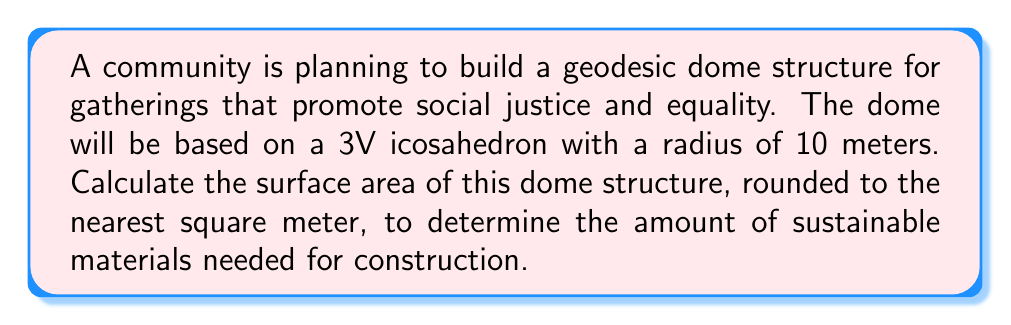Solve this math problem. To calculate the surface area of a geodesic dome based on a 3V icosahedron, we'll follow these steps:

1. Calculate the number of triangles:
   A 3V icosahedron has $10T + 20T = 30T$ triangles, where $T = 3^2 = 9$.
   Total triangles = $30 \times 9 = 270$

2. Calculate the surface area of one spherical triangle:
   The formula for the surface area of a spherical triangle is:
   $A = R^2 \times (\alpha + \beta + \gamma - \pi)$
   Where $R$ is the radius, and $\alpha$, $\beta$, and $\gamma$ are the angles of the spherical triangle.

   For a 3V icosahedron, the angles are approximately:
   $\alpha \approx \beta \approx \gamma \approx 72°$

   Converting to radians:
   $72° \times \frac{\pi}{180°} = 1.2566$ radians

   Surface area of one triangle:
   $A = 10^2 \times (1.2566 + 1.2566 + 1.2566 - \pi)$
   $A = 100 \times (3.7698 - 3.1416)$
   $A = 100 \times 0.6282 = 62.82$ m²

3. Calculate the total surface area:
   Total surface area = Number of triangles × Area of one triangle
   $SA = 270 \times 62.82 = 16,961.4$ m²

4. Round to the nearest square meter:
   $SA \approx 16,961$ m²
Answer: 16,961 m² 